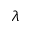Convert formula to latex. <formula><loc_0><loc_0><loc_500><loc_500>\lambda</formula> 